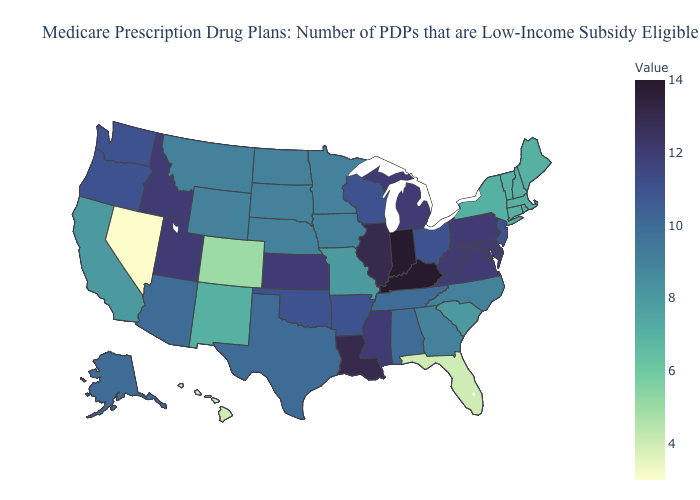Which states have the lowest value in the USA?
Short answer required. Nevada. Does Kansas have the lowest value in the USA?
Be succinct. No. Is the legend a continuous bar?
Short answer required. Yes. Among the states that border Texas , which have the highest value?
Give a very brief answer. Louisiana. Does Nevada have the lowest value in the West?
Concise answer only. Yes. Which states have the highest value in the USA?
Short answer required. Indiana, Kentucky. 